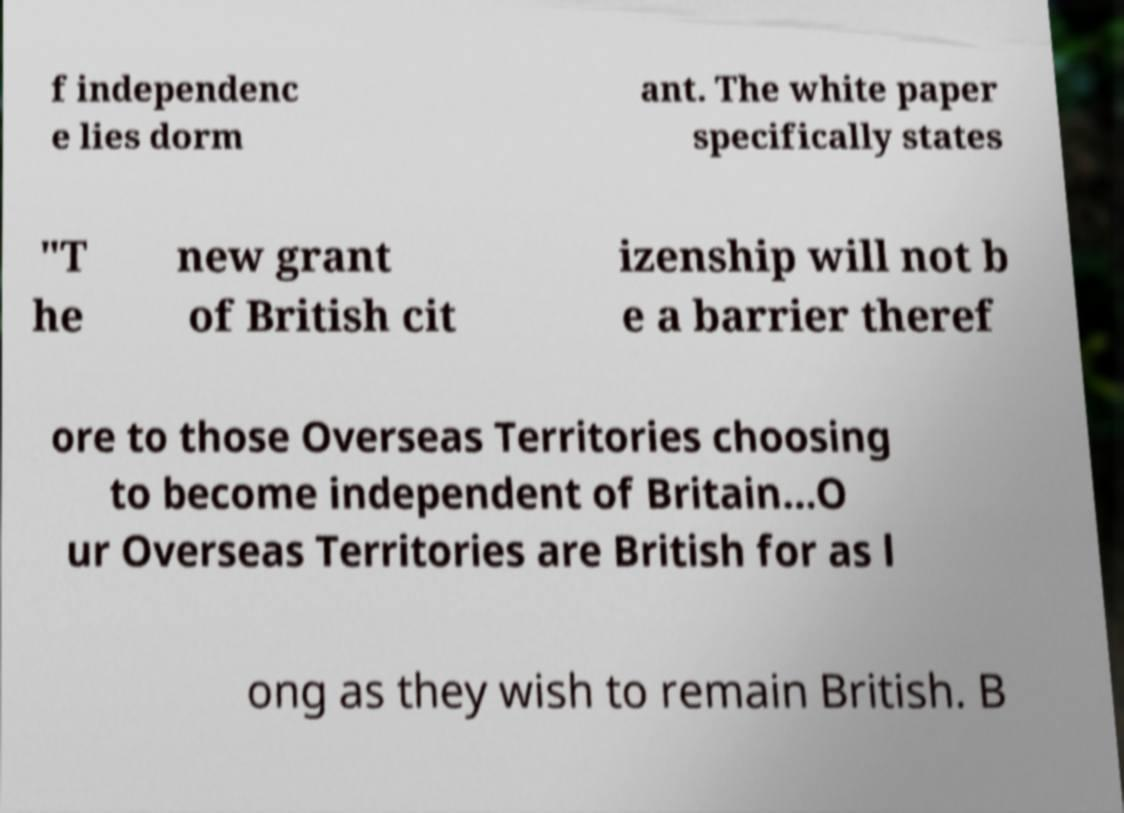Could you assist in decoding the text presented in this image and type it out clearly? f independenc e lies dorm ant. The white paper specifically states "T he new grant of British cit izenship will not b e a barrier theref ore to those Overseas Territories choosing to become independent of Britain...O ur Overseas Territories are British for as l ong as they wish to remain British. B 